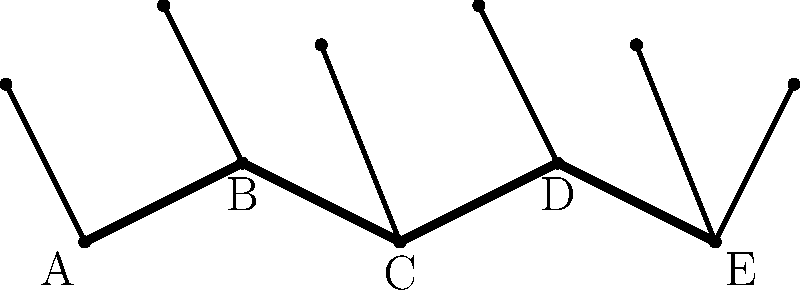In the stick figure representation of a hydra's locomotion, points A, B, C, D, and E represent key positions of the creature's body during movement. If the hydra moves with a sinusoidal wave pattern, which mathematical function best describes the vertical displacement of these points over time, and how might this affect the creature's overall speed and efficiency? To answer this question, let's break down the analysis step-by-step:

1. Sinusoidal wave pattern: The hydra's body forms a wave-like shape, which is characteristic of sinusoidal motion.

2. Mathematical representation: The vertical displacement of points A, B, C, D, and E can be described by a sine function:

   $$y(x,t) = A \sin(kx - \omega t + \phi)$$

   Where:
   - $y$ is the vertical displacement
   - $A$ is the amplitude (half the height of the wave)
   - $k$ is the wave number (related to wavelength)
   - $x$ is the position along the body
   - $\omega$ is the angular frequency
   - $t$ is time
   - $\phi$ is the phase shift

3. Effect on speed and efficiency:
   a) Amplitude ($A$): Larger amplitude increases displacement but requires more energy.
   b) Wavelength ($\lambda = \frac{2\pi}{k}$): Affects the number of waves along the body.
   c) Frequency ($f = \frac{\omega}{2\pi}$): Higher frequency can increase speed but requires more energy.

4. Speed calculation: The wave speed is given by:

   $$v = \lambda f = \frac{\omega}{k}$$

5. Efficiency considerations:
   - Optimal wavelength: Usually close to the body length for maximum efficiency.
   - Amplitude and frequency trade-off: Balancing these parameters can optimize energy use.

6. Multiple heads: The hydra's multiple heads may contribute to stability and steering, potentially affecting the overall locomotion efficiency.

In folklore and mythology, the hydra's multiple heads are often associated with regeneration and adaptability. From a biomechanical perspective, this multi-headed structure could provide advantages in terms of sensory input and directional control during locomotion.
Answer: Sine function; speed and efficiency depend on amplitude, wavelength, and frequency optimization. 